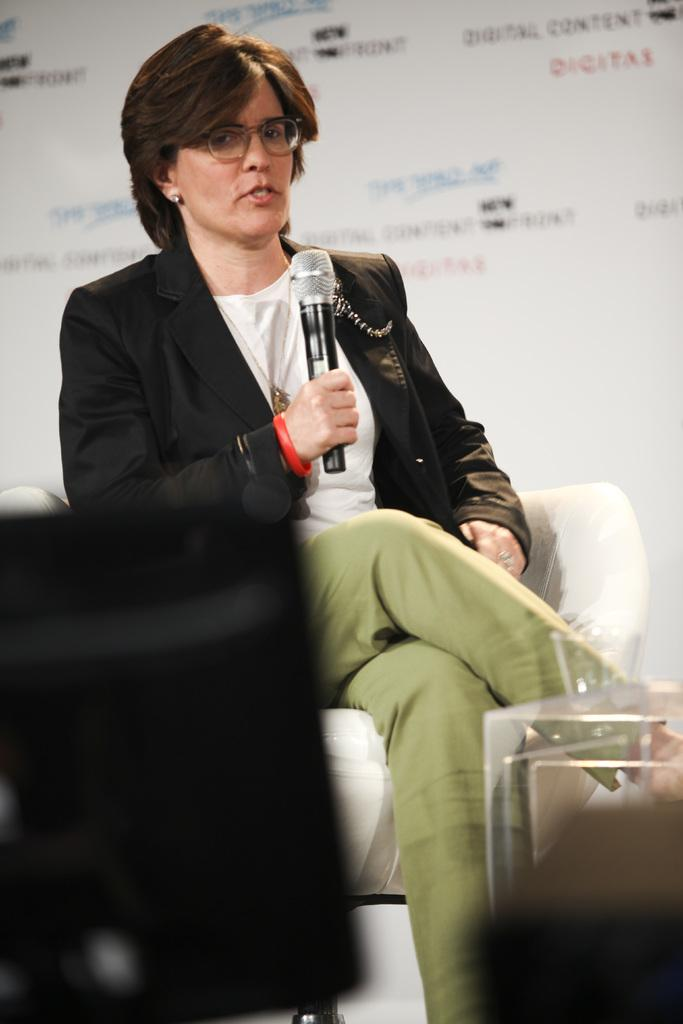Who is the main subject in the image? There is a woman in the image. What is the woman wearing? The woman is wearing a black suit. What is the woman doing in the image? The woman is talking on a mic. What is the woman sitting on in the image? The woman is sitting on a white chair. What can be seen behind the woman in the image? There is a white banner behind the woman. Can you see the woman's friend tying a knot on the stage in the image? There is no friend or stage present in the image, and no one is tying a knot. 